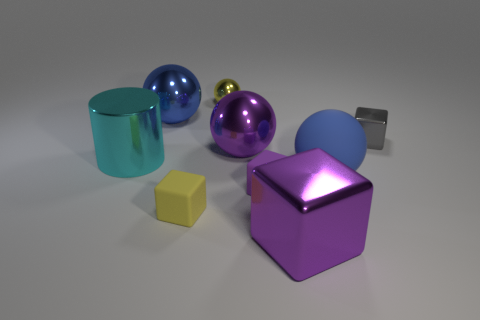What material is the yellow cube that is the same size as the gray thing?
Provide a succinct answer. Rubber. Is the number of blue objects that are on the left side of the blue rubber thing less than the number of small yellow matte objects?
Your response must be concise. No. There is a small gray shiny object that is right of the small shiny object on the left side of the blue object to the right of the tiny ball; what is its shape?
Make the answer very short. Cube. How big is the yellow thing that is in front of the gray object?
Your answer should be very brief. Small. What shape is the blue metallic object that is the same size as the rubber ball?
Ensure brevity in your answer.  Sphere. How many things are either large metallic blocks or shiny blocks that are on the left side of the small metal block?
Offer a terse response. 1. There is a blue object that is right of the small yellow object that is behind the blue metal object; how many objects are in front of it?
Ensure brevity in your answer.  3. There is a small thing that is made of the same material as the tiny yellow sphere; what is its color?
Keep it short and to the point. Gray. There is a metal cube that is behind the cyan cylinder; does it have the same size as the yellow block?
Your answer should be very brief. Yes. How many objects are matte cubes or yellow metal things?
Offer a very short reply. 3. 